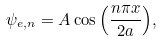<formula> <loc_0><loc_0><loc_500><loc_500>\psi _ { e , n } = A \cos { \left ( \frac { n \pi x } { 2 a } \right ) } ,</formula> 